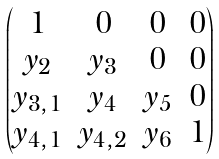Convert formula to latex. <formula><loc_0><loc_0><loc_500><loc_500>\begin{pmatrix} 1 & 0 & 0 & 0 \\ y _ { 2 } & y _ { 3 } & 0 & 0 \\ y _ { 3 , 1 } & y _ { 4 } & y _ { 5 } & 0 \\ y _ { 4 , 1 } & y _ { 4 , 2 } & y _ { 6 } & 1 \end{pmatrix}</formula> 